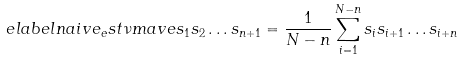<formula> <loc_0><loc_0><loc_500><loc_500>\ e l a b e l { n a i v e _ { e } s t } \nu m a v e { s _ { 1 } s _ { 2 } \dots s _ { n + 1 } } = \frac { 1 } { N - n } \sum _ { i = 1 } ^ { N - n } s _ { i } s _ { i + 1 } \dots s _ { i + n }</formula> 